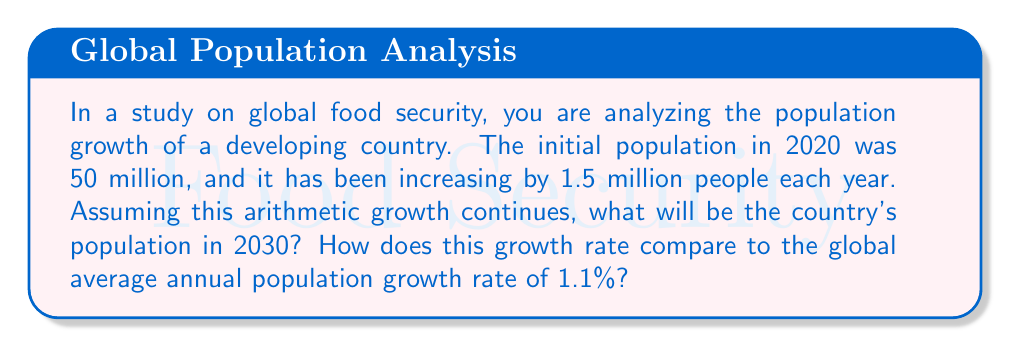What is the answer to this math problem? Let's approach this step-by-step:

1) We're dealing with an arithmetic sequence where:
   - Initial population (a₁) = 50 million
   - Common difference (d) = 1.5 million
   - Number of years (n) = 10 (from 2020 to 2030)

2) The formula for the nth term of an arithmetic sequence is:
   $$ a_n = a_1 + (n-1)d $$

3) Plugging in our values:
   $$ a_{10} = 50 + (10-1)(1.5) = 50 + (9)(1.5) = 50 + 13.5 = 63.5 $$

4) Therefore, the population in 2030 will be 63.5 million.

5) To calculate the growth rate:
   - Total growth: 63.5 - 50 = 13.5 million
   - Growth rate = (Total growth / Initial population) / Number of years
   $$ \text{Growth rate} = \frac{13.5}{50} \div 10 = 0.027 = 2.7\% $$

6) Comparing to the global average:
   - Country's annual growth rate: 2.7%
   - Global average annual growth rate: 1.1%
   - The country's growth rate is $\frac{2.7}{1.1} \approx 2.45$ times the global average
Answer: 63.5 million; 2.7% annually, 2.45 times global average 